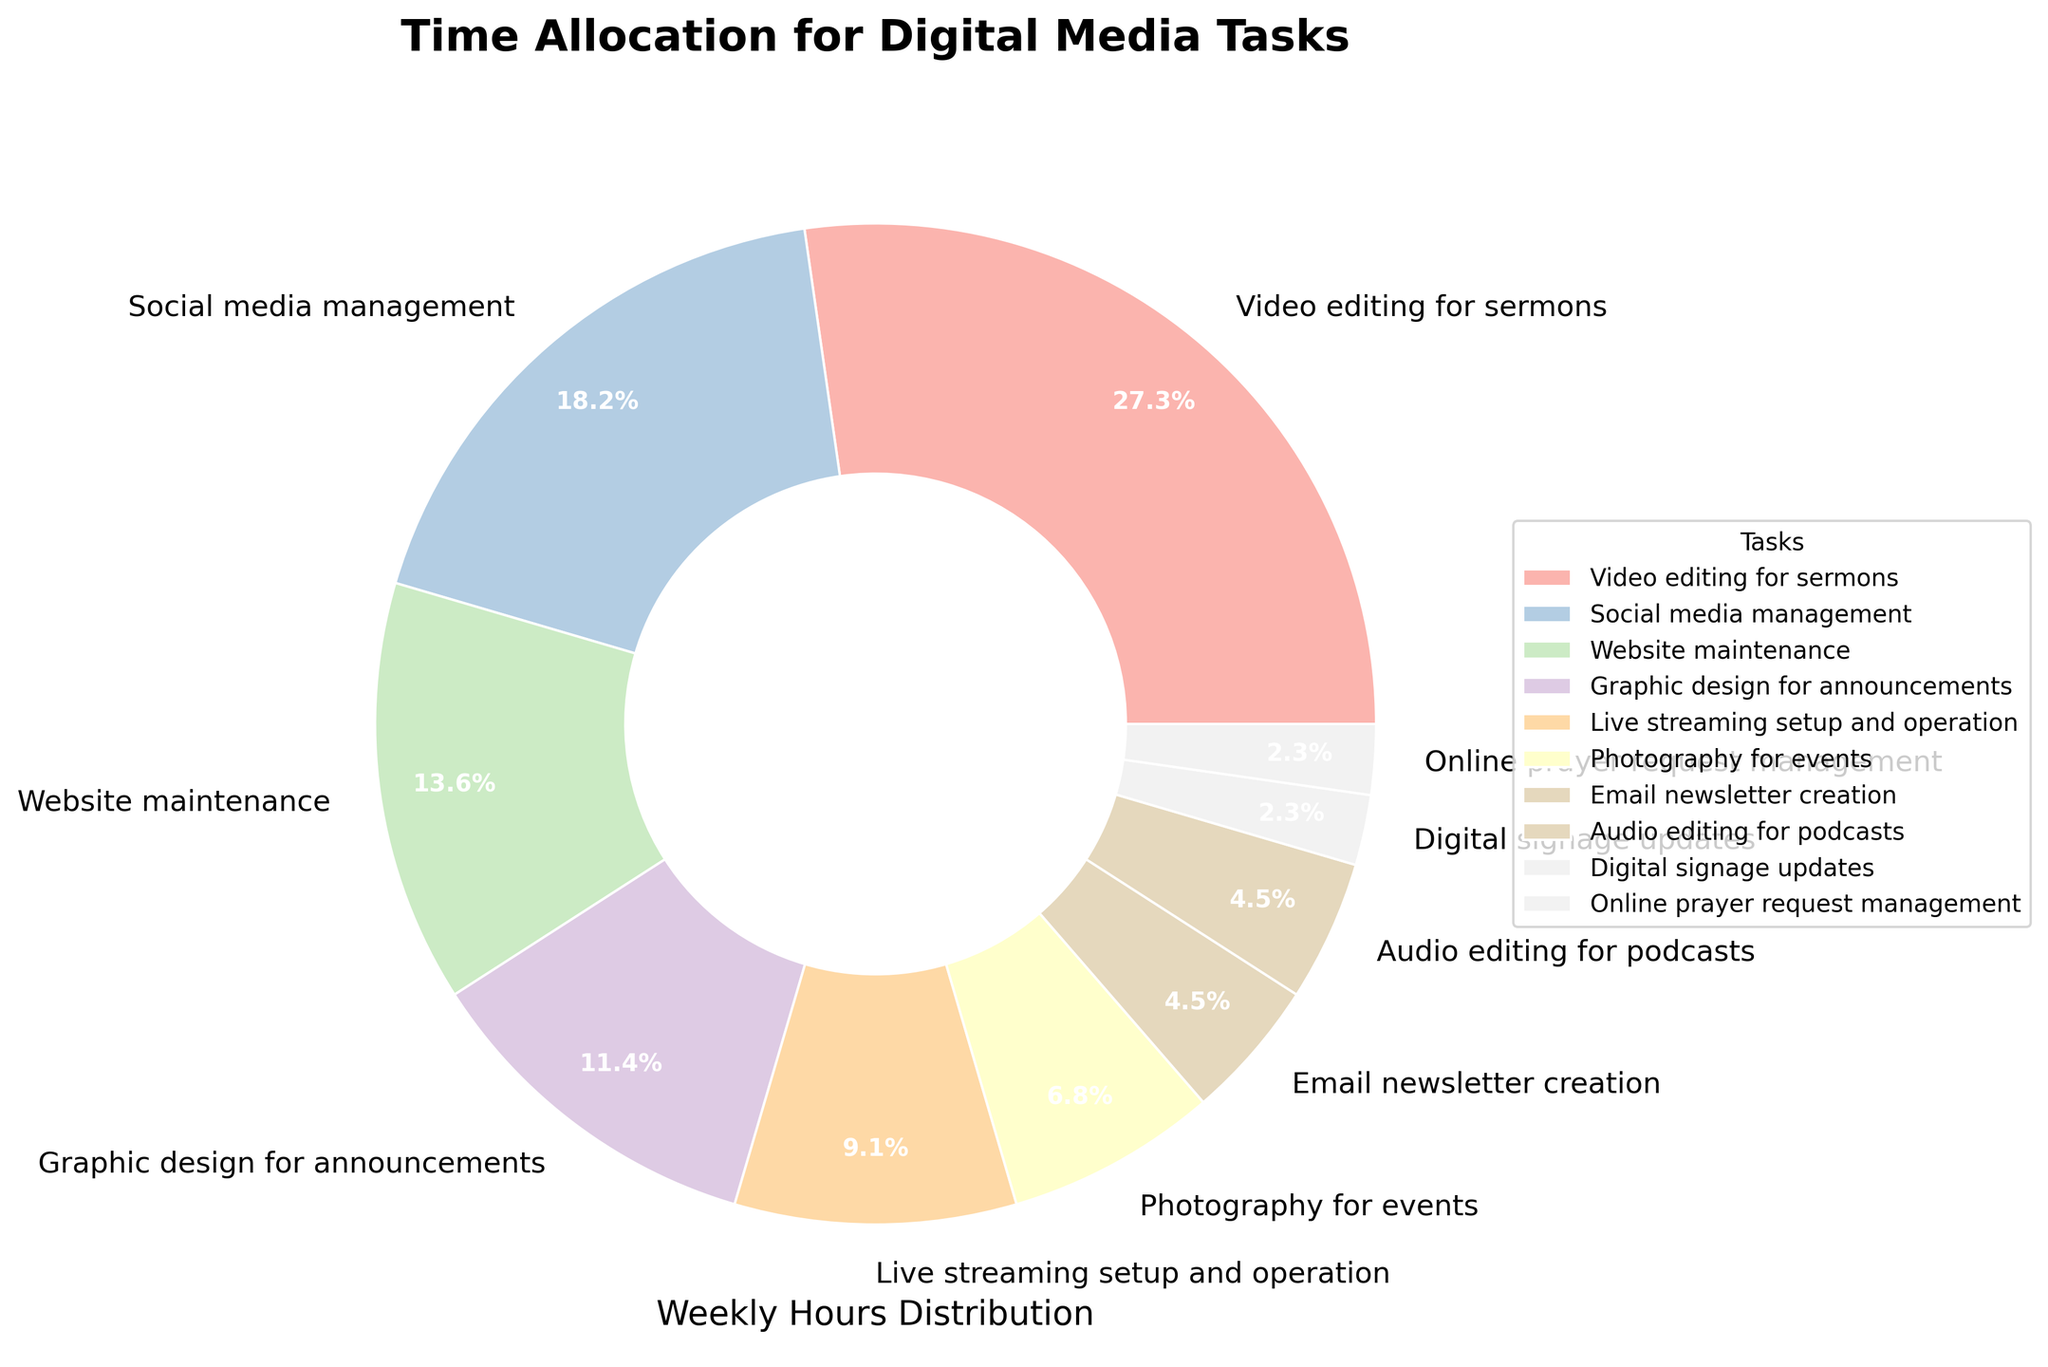Which task takes up the most time each week? The task with the largest segment or the highest percentage on the pie chart is the one that takes up the most time each week. "Video editing for sermons" has the largest segment and 12 hours per week.
Answer: Video editing for sermons How many hours are spent on tasks related to visual content (Video editing, Graphic design, Photography)? Add the hours for "Video editing for sermons" (12), "Graphic design for announcements" (5), and "Photography for events" (3). 12 + 5 + 3 = 20 hours.
Answer: 20 hours Which task takes less time each week, Email newsletter creation or Online prayer request management? Compare the two smallest segments on the pie chart: "Email newsletter creation" and "Online prayer request management". "Online prayer request management" (1 hour) takes less time than "Email newsletter creation" (2 hours).
Answer: Online prayer request management Is more or less time spent on Website maintenance compared to Social media management? Compare the segments labeled "Website maintenance" and "Social media management." "Social media management" (8 hours) is larger than "Website maintenance" (6 hours), indicating more time is spent on social media.
Answer: More time What is the combined percentage of time spent on Social media management and Website maintenance? The percentages for "Social media management" (8 hours) and "Website maintenance" (6 hours) can be added together. First, calculate their combined hours as 8 + 6 = 14. To convert this to a percentage, use the total hours (42): (14/42) * 100 ≈ 33.3%.
Answer: 33.3% Which category has a greater percentage of time, Audio editing for podcasts or Live streaming setup and operation? Compare the segments of "Audio editing for podcasts" and "Live streaming setup and operation." "Live streaming setup and operation" (4 hours) is greater than "Audio editing for podcasts" (2 hours).
Answer: Live streaming setup and operation How much more time is spent on Video editing for sermons than on Live streaming setup and operation? Subtract the hours for "Live streaming setup and operation" from the hours for "Video editing for sermons": 12 - 4 = 8 hours.
Answer: 8 hours 